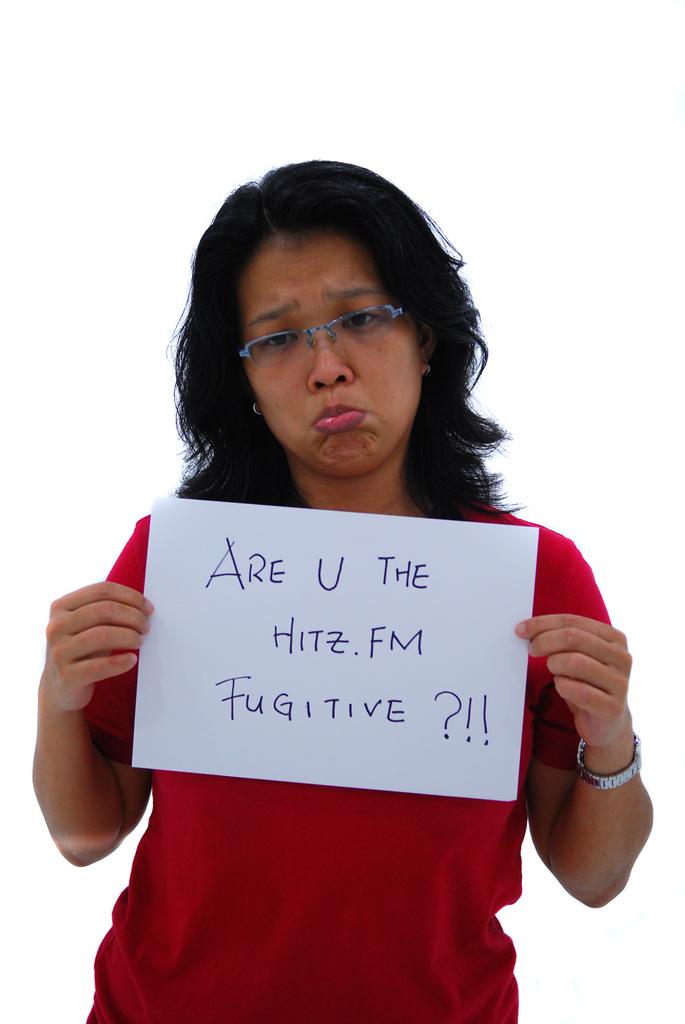What does her sign say?
Offer a very short reply. Are u the hitz.fm fugitive?!!. 